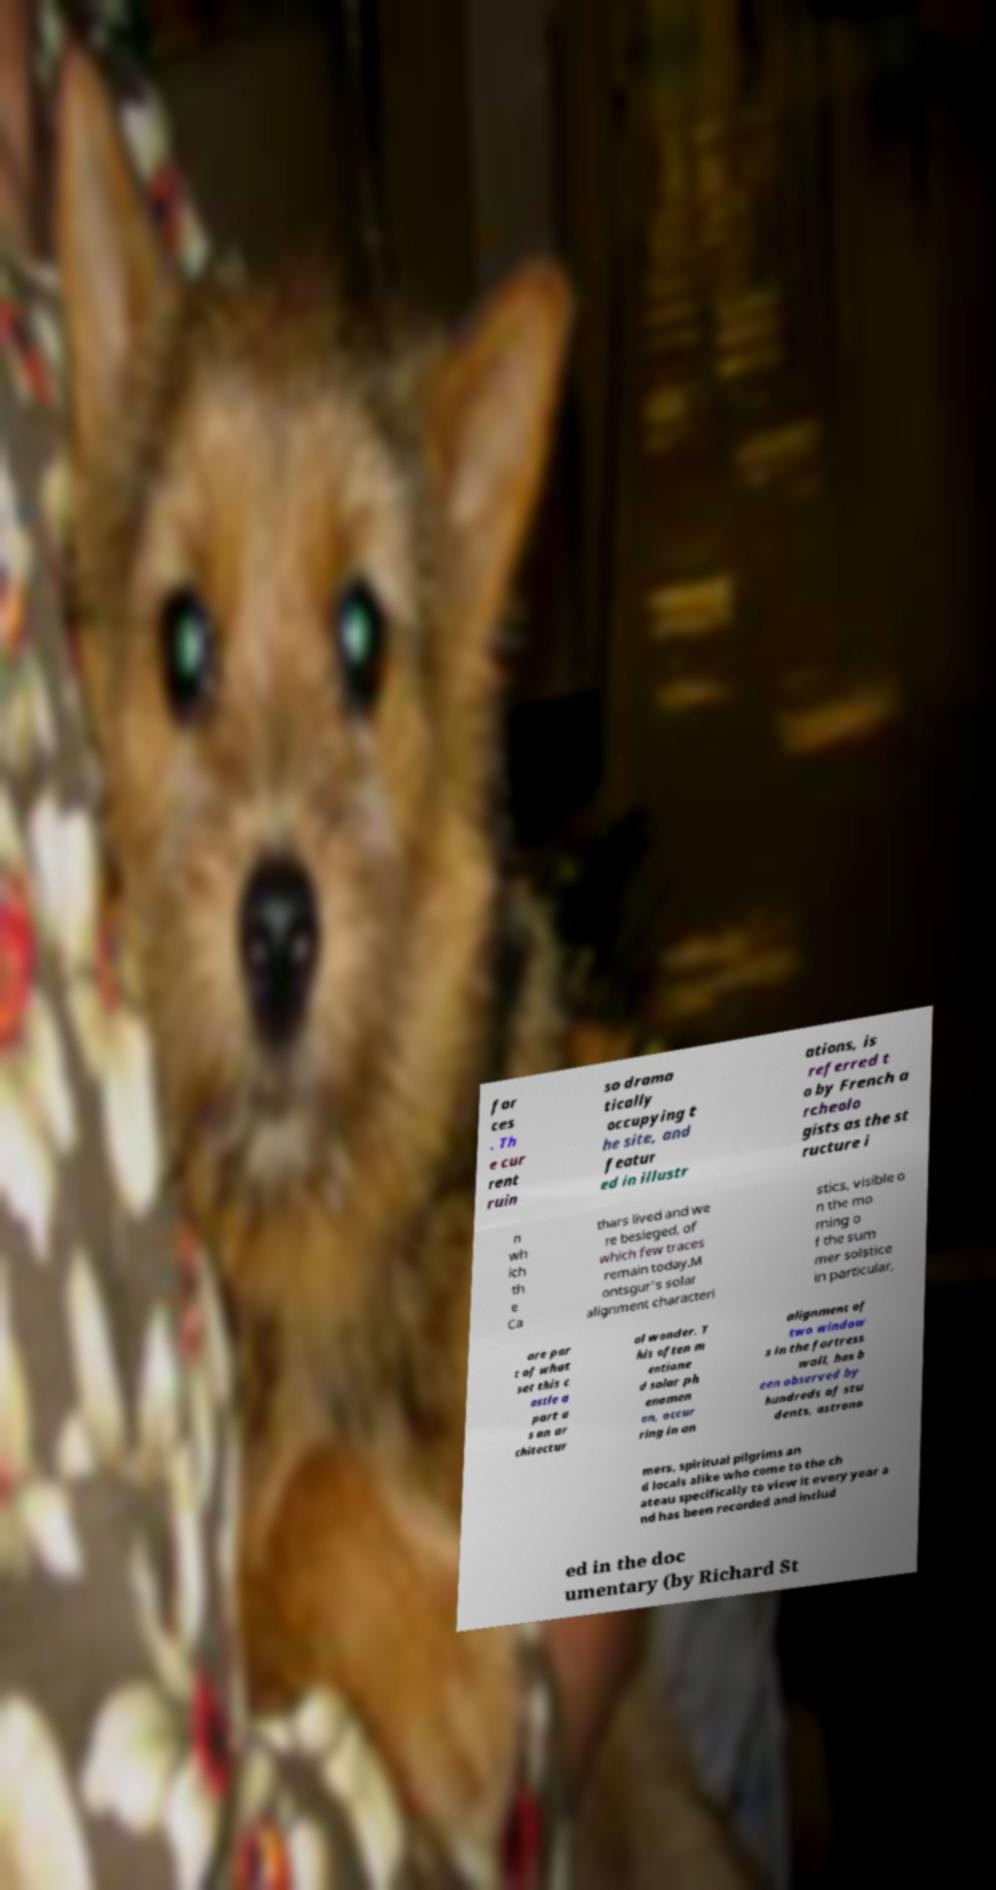Please read and relay the text visible in this image. What does it say? for ces . Th e cur rent ruin so drama tically occupying t he site, and featur ed in illustr ations, is referred t o by French a rcheolo gists as the st ructure i n wh ich th e Ca thars lived and we re besieged, of which few traces remain today.M ontsgur's solar alignment characteri stics, visible o n the mo rning o f the sum mer solstice in particular, are par t of what set this c astle a part a s an ar chitectur al wonder. T his often m entione d solar ph enomen on, occur ring in an alignment of two window s in the fortress wall, has b een observed by hundreds of stu dents, astrono mers, spiritual pilgrims an d locals alike who come to the ch ateau specifically to view it every year a nd has been recorded and includ ed in the doc umentary (by Richard St 